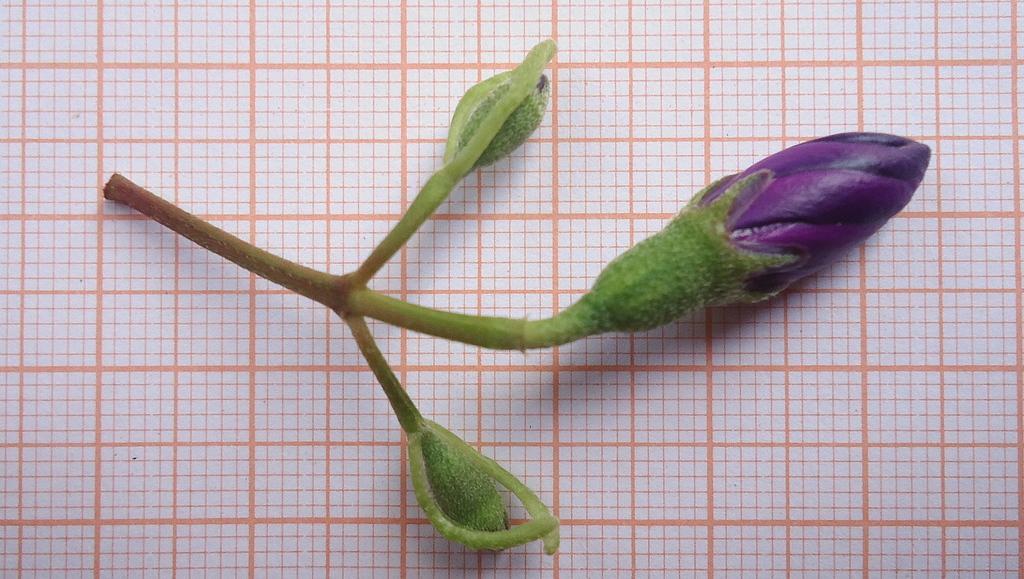Can you describe this image briefly? In this image I can see the flower bud which is green and purple in color on the paper which is white and orange in color. 